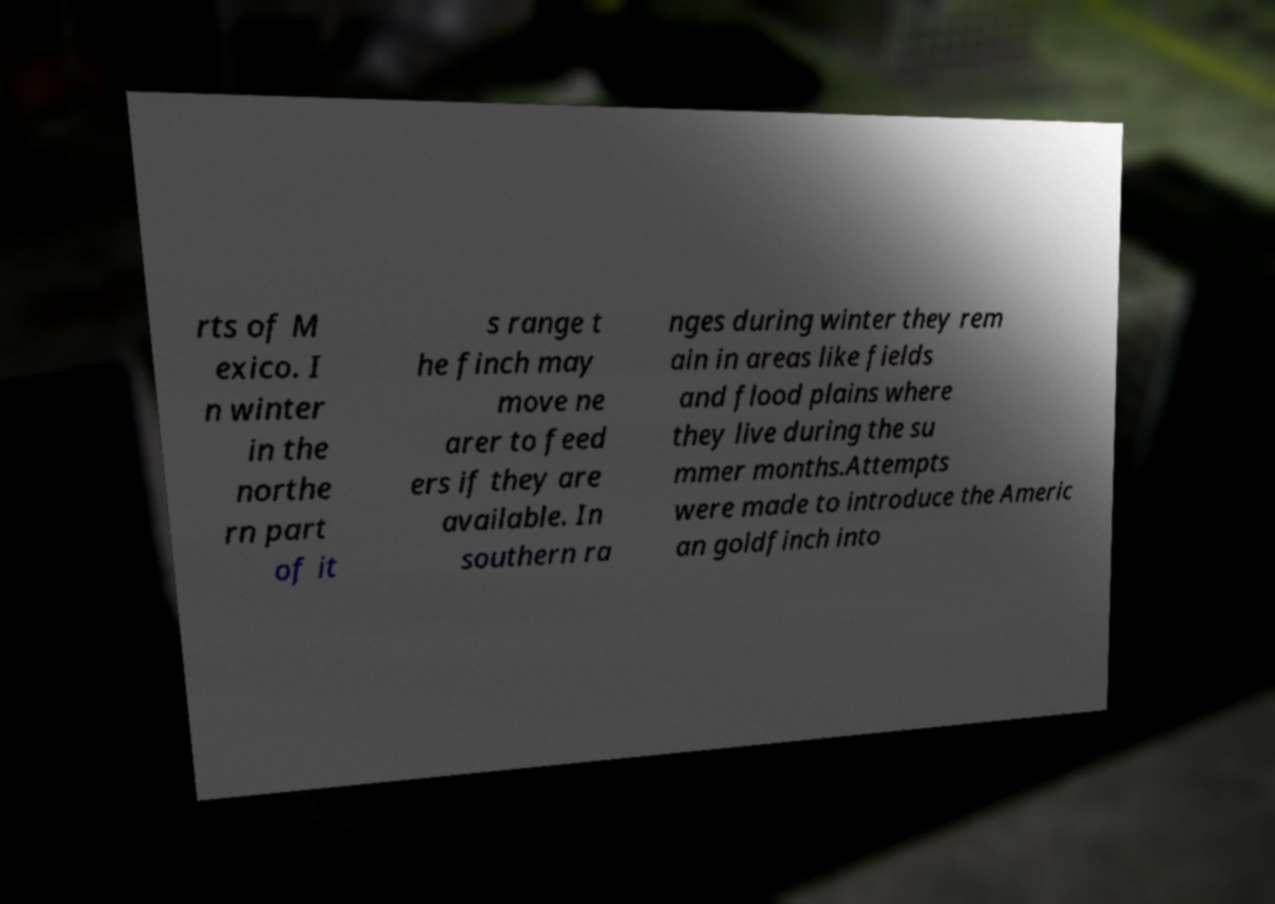For documentation purposes, I need the text within this image transcribed. Could you provide that? rts of M exico. I n winter in the northe rn part of it s range t he finch may move ne arer to feed ers if they are available. In southern ra nges during winter they rem ain in areas like fields and flood plains where they live during the su mmer months.Attempts were made to introduce the Americ an goldfinch into 